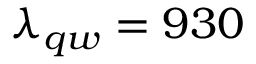Convert formula to latex. <formula><loc_0><loc_0><loc_500><loc_500>\lambda _ { q w } = 9 3 0</formula> 